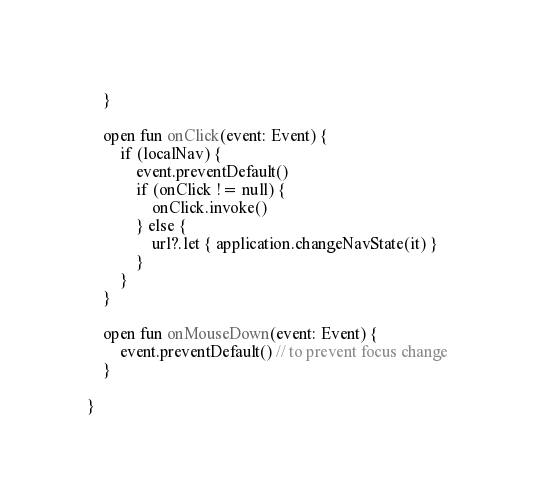<code> <loc_0><loc_0><loc_500><loc_500><_Kotlin_>
    }

    open fun onClick(event: Event) {
        if (localNav) {
            event.preventDefault()
            if (onClick != null) {
                onClick.invoke()
            } else {
                url?.let { application.changeNavState(it) }
            }
        }
    }

    open fun onMouseDown(event: Event) {
        event.preventDefault() // to prevent focus change
    }

}</code> 